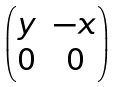<formula> <loc_0><loc_0><loc_500><loc_500>\begin{pmatrix} y & - x \\ 0 & 0 \end{pmatrix}</formula> 